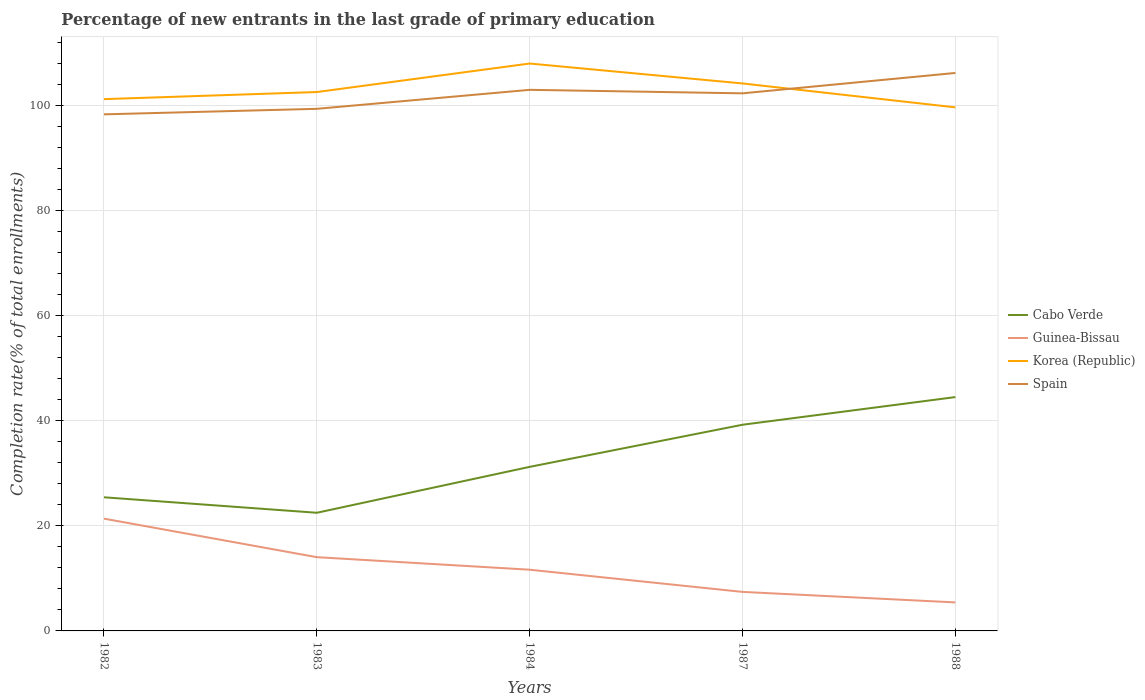How many different coloured lines are there?
Your answer should be compact. 4. Does the line corresponding to Cabo Verde intersect with the line corresponding to Korea (Republic)?
Keep it short and to the point. No. Is the number of lines equal to the number of legend labels?
Your answer should be very brief. Yes. Across all years, what is the maximum percentage of new entrants in Spain?
Offer a terse response. 98.31. What is the total percentage of new entrants in Cabo Verde in the graph?
Your answer should be very brief. -13.28. What is the difference between the highest and the second highest percentage of new entrants in Spain?
Provide a succinct answer. 7.88. What is the difference between the highest and the lowest percentage of new entrants in Korea (Republic)?
Your answer should be compact. 2. Is the percentage of new entrants in Cabo Verde strictly greater than the percentage of new entrants in Spain over the years?
Your answer should be compact. Yes. How many years are there in the graph?
Your response must be concise. 5. Where does the legend appear in the graph?
Make the answer very short. Center right. How many legend labels are there?
Keep it short and to the point. 4. What is the title of the graph?
Provide a short and direct response. Percentage of new entrants in the last grade of primary education. What is the label or title of the Y-axis?
Your answer should be compact. Completion rate(% of total enrollments). What is the Completion rate(% of total enrollments) in Cabo Verde in 1982?
Your answer should be compact. 25.43. What is the Completion rate(% of total enrollments) in Guinea-Bissau in 1982?
Offer a very short reply. 21.37. What is the Completion rate(% of total enrollments) of Korea (Republic) in 1982?
Your answer should be compact. 101.2. What is the Completion rate(% of total enrollments) in Spain in 1982?
Offer a very short reply. 98.31. What is the Completion rate(% of total enrollments) of Cabo Verde in 1983?
Make the answer very short. 22.48. What is the Completion rate(% of total enrollments) of Guinea-Bissau in 1983?
Ensure brevity in your answer.  14.03. What is the Completion rate(% of total enrollments) of Korea (Republic) in 1983?
Offer a terse response. 102.55. What is the Completion rate(% of total enrollments) in Spain in 1983?
Keep it short and to the point. 99.36. What is the Completion rate(% of total enrollments) of Cabo Verde in 1984?
Give a very brief answer. 31.22. What is the Completion rate(% of total enrollments) in Guinea-Bissau in 1984?
Keep it short and to the point. 11.65. What is the Completion rate(% of total enrollments) of Korea (Republic) in 1984?
Keep it short and to the point. 107.98. What is the Completion rate(% of total enrollments) in Spain in 1984?
Offer a terse response. 102.97. What is the Completion rate(% of total enrollments) in Cabo Verde in 1987?
Your response must be concise. 39.24. What is the Completion rate(% of total enrollments) of Guinea-Bissau in 1987?
Keep it short and to the point. 7.43. What is the Completion rate(% of total enrollments) in Korea (Republic) in 1987?
Ensure brevity in your answer.  104.18. What is the Completion rate(% of total enrollments) of Spain in 1987?
Offer a very short reply. 102.31. What is the Completion rate(% of total enrollments) in Cabo Verde in 1988?
Offer a terse response. 44.5. What is the Completion rate(% of total enrollments) in Guinea-Bissau in 1988?
Ensure brevity in your answer.  5.42. What is the Completion rate(% of total enrollments) of Korea (Republic) in 1988?
Offer a very short reply. 99.63. What is the Completion rate(% of total enrollments) in Spain in 1988?
Provide a short and direct response. 106.18. Across all years, what is the maximum Completion rate(% of total enrollments) in Cabo Verde?
Offer a very short reply. 44.5. Across all years, what is the maximum Completion rate(% of total enrollments) of Guinea-Bissau?
Offer a very short reply. 21.37. Across all years, what is the maximum Completion rate(% of total enrollments) in Korea (Republic)?
Your response must be concise. 107.98. Across all years, what is the maximum Completion rate(% of total enrollments) in Spain?
Give a very brief answer. 106.18. Across all years, what is the minimum Completion rate(% of total enrollments) in Cabo Verde?
Offer a terse response. 22.48. Across all years, what is the minimum Completion rate(% of total enrollments) in Guinea-Bissau?
Keep it short and to the point. 5.42. Across all years, what is the minimum Completion rate(% of total enrollments) in Korea (Republic)?
Offer a very short reply. 99.63. Across all years, what is the minimum Completion rate(% of total enrollments) in Spain?
Ensure brevity in your answer.  98.31. What is the total Completion rate(% of total enrollments) of Cabo Verde in the graph?
Your answer should be very brief. 162.87. What is the total Completion rate(% of total enrollments) in Guinea-Bissau in the graph?
Keep it short and to the point. 59.9. What is the total Completion rate(% of total enrollments) in Korea (Republic) in the graph?
Offer a very short reply. 515.55. What is the total Completion rate(% of total enrollments) in Spain in the graph?
Your answer should be very brief. 509.12. What is the difference between the Completion rate(% of total enrollments) in Cabo Verde in 1982 and that in 1983?
Your response must be concise. 2.95. What is the difference between the Completion rate(% of total enrollments) of Guinea-Bissau in 1982 and that in 1983?
Make the answer very short. 7.33. What is the difference between the Completion rate(% of total enrollments) of Korea (Republic) in 1982 and that in 1983?
Your answer should be very brief. -1.35. What is the difference between the Completion rate(% of total enrollments) of Spain in 1982 and that in 1983?
Your answer should be compact. -1.05. What is the difference between the Completion rate(% of total enrollments) of Cabo Verde in 1982 and that in 1984?
Offer a terse response. -5.79. What is the difference between the Completion rate(% of total enrollments) of Guinea-Bissau in 1982 and that in 1984?
Offer a very short reply. 9.72. What is the difference between the Completion rate(% of total enrollments) in Korea (Republic) in 1982 and that in 1984?
Give a very brief answer. -6.78. What is the difference between the Completion rate(% of total enrollments) of Spain in 1982 and that in 1984?
Give a very brief answer. -4.66. What is the difference between the Completion rate(% of total enrollments) in Cabo Verde in 1982 and that in 1987?
Make the answer very short. -13.81. What is the difference between the Completion rate(% of total enrollments) in Guinea-Bissau in 1982 and that in 1987?
Give a very brief answer. 13.94. What is the difference between the Completion rate(% of total enrollments) in Korea (Republic) in 1982 and that in 1987?
Provide a succinct answer. -2.98. What is the difference between the Completion rate(% of total enrollments) of Spain in 1982 and that in 1987?
Your response must be concise. -4. What is the difference between the Completion rate(% of total enrollments) of Cabo Verde in 1982 and that in 1988?
Give a very brief answer. -19.07. What is the difference between the Completion rate(% of total enrollments) in Guinea-Bissau in 1982 and that in 1988?
Provide a succinct answer. 15.94. What is the difference between the Completion rate(% of total enrollments) of Korea (Republic) in 1982 and that in 1988?
Ensure brevity in your answer.  1.57. What is the difference between the Completion rate(% of total enrollments) of Spain in 1982 and that in 1988?
Offer a very short reply. -7.88. What is the difference between the Completion rate(% of total enrollments) of Cabo Verde in 1983 and that in 1984?
Make the answer very short. -8.74. What is the difference between the Completion rate(% of total enrollments) in Guinea-Bissau in 1983 and that in 1984?
Provide a short and direct response. 2.39. What is the difference between the Completion rate(% of total enrollments) in Korea (Republic) in 1983 and that in 1984?
Your answer should be very brief. -5.43. What is the difference between the Completion rate(% of total enrollments) in Spain in 1983 and that in 1984?
Offer a very short reply. -3.61. What is the difference between the Completion rate(% of total enrollments) in Cabo Verde in 1983 and that in 1987?
Offer a terse response. -16.75. What is the difference between the Completion rate(% of total enrollments) of Guinea-Bissau in 1983 and that in 1987?
Your answer should be compact. 6.61. What is the difference between the Completion rate(% of total enrollments) in Korea (Republic) in 1983 and that in 1987?
Your answer should be compact. -1.63. What is the difference between the Completion rate(% of total enrollments) in Spain in 1983 and that in 1987?
Provide a short and direct response. -2.95. What is the difference between the Completion rate(% of total enrollments) in Cabo Verde in 1983 and that in 1988?
Provide a short and direct response. -22.01. What is the difference between the Completion rate(% of total enrollments) of Guinea-Bissau in 1983 and that in 1988?
Provide a succinct answer. 8.61. What is the difference between the Completion rate(% of total enrollments) in Korea (Republic) in 1983 and that in 1988?
Offer a very short reply. 2.92. What is the difference between the Completion rate(% of total enrollments) in Spain in 1983 and that in 1988?
Your response must be concise. -6.83. What is the difference between the Completion rate(% of total enrollments) in Cabo Verde in 1984 and that in 1987?
Your answer should be compact. -8.01. What is the difference between the Completion rate(% of total enrollments) in Guinea-Bissau in 1984 and that in 1987?
Give a very brief answer. 4.22. What is the difference between the Completion rate(% of total enrollments) in Korea (Republic) in 1984 and that in 1987?
Offer a terse response. 3.79. What is the difference between the Completion rate(% of total enrollments) of Spain in 1984 and that in 1987?
Offer a very short reply. 0.66. What is the difference between the Completion rate(% of total enrollments) of Cabo Verde in 1984 and that in 1988?
Offer a terse response. -13.28. What is the difference between the Completion rate(% of total enrollments) of Guinea-Bissau in 1984 and that in 1988?
Make the answer very short. 6.22. What is the difference between the Completion rate(% of total enrollments) of Korea (Republic) in 1984 and that in 1988?
Offer a terse response. 8.34. What is the difference between the Completion rate(% of total enrollments) of Spain in 1984 and that in 1988?
Your response must be concise. -3.21. What is the difference between the Completion rate(% of total enrollments) of Cabo Verde in 1987 and that in 1988?
Ensure brevity in your answer.  -5.26. What is the difference between the Completion rate(% of total enrollments) in Guinea-Bissau in 1987 and that in 1988?
Offer a very short reply. 2. What is the difference between the Completion rate(% of total enrollments) in Korea (Republic) in 1987 and that in 1988?
Make the answer very short. 4.55. What is the difference between the Completion rate(% of total enrollments) of Spain in 1987 and that in 1988?
Your answer should be compact. -3.88. What is the difference between the Completion rate(% of total enrollments) of Cabo Verde in 1982 and the Completion rate(% of total enrollments) of Guinea-Bissau in 1983?
Provide a succinct answer. 11.4. What is the difference between the Completion rate(% of total enrollments) of Cabo Verde in 1982 and the Completion rate(% of total enrollments) of Korea (Republic) in 1983?
Ensure brevity in your answer.  -77.12. What is the difference between the Completion rate(% of total enrollments) of Cabo Verde in 1982 and the Completion rate(% of total enrollments) of Spain in 1983?
Offer a very short reply. -73.93. What is the difference between the Completion rate(% of total enrollments) in Guinea-Bissau in 1982 and the Completion rate(% of total enrollments) in Korea (Republic) in 1983?
Keep it short and to the point. -81.18. What is the difference between the Completion rate(% of total enrollments) in Guinea-Bissau in 1982 and the Completion rate(% of total enrollments) in Spain in 1983?
Keep it short and to the point. -77.99. What is the difference between the Completion rate(% of total enrollments) of Korea (Republic) in 1982 and the Completion rate(% of total enrollments) of Spain in 1983?
Keep it short and to the point. 1.84. What is the difference between the Completion rate(% of total enrollments) in Cabo Verde in 1982 and the Completion rate(% of total enrollments) in Guinea-Bissau in 1984?
Provide a succinct answer. 13.78. What is the difference between the Completion rate(% of total enrollments) in Cabo Verde in 1982 and the Completion rate(% of total enrollments) in Korea (Republic) in 1984?
Ensure brevity in your answer.  -82.55. What is the difference between the Completion rate(% of total enrollments) of Cabo Verde in 1982 and the Completion rate(% of total enrollments) of Spain in 1984?
Offer a terse response. -77.54. What is the difference between the Completion rate(% of total enrollments) in Guinea-Bissau in 1982 and the Completion rate(% of total enrollments) in Korea (Republic) in 1984?
Your response must be concise. -86.61. What is the difference between the Completion rate(% of total enrollments) of Guinea-Bissau in 1982 and the Completion rate(% of total enrollments) of Spain in 1984?
Keep it short and to the point. -81.6. What is the difference between the Completion rate(% of total enrollments) in Korea (Republic) in 1982 and the Completion rate(% of total enrollments) in Spain in 1984?
Keep it short and to the point. -1.77. What is the difference between the Completion rate(% of total enrollments) of Cabo Verde in 1982 and the Completion rate(% of total enrollments) of Guinea-Bissau in 1987?
Your response must be concise. 18. What is the difference between the Completion rate(% of total enrollments) of Cabo Verde in 1982 and the Completion rate(% of total enrollments) of Korea (Republic) in 1987?
Your response must be concise. -78.75. What is the difference between the Completion rate(% of total enrollments) in Cabo Verde in 1982 and the Completion rate(% of total enrollments) in Spain in 1987?
Your answer should be very brief. -76.88. What is the difference between the Completion rate(% of total enrollments) in Guinea-Bissau in 1982 and the Completion rate(% of total enrollments) in Korea (Republic) in 1987?
Your answer should be compact. -82.82. What is the difference between the Completion rate(% of total enrollments) in Guinea-Bissau in 1982 and the Completion rate(% of total enrollments) in Spain in 1987?
Give a very brief answer. -80.94. What is the difference between the Completion rate(% of total enrollments) of Korea (Republic) in 1982 and the Completion rate(% of total enrollments) of Spain in 1987?
Provide a succinct answer. -1.11. What is the difference between the Completion rate(% of total enrollments) in Cabo Verde in 1982 and the Completion rate(% of total enrollments) in Guinea-Bissau in 1988?
Keep it short and to the point. 20.01. What is the difference between the Completion rate(% of total enrollments) in Cabo Verde in 1982 and the Completion rate(% of total enrollments) in Korea (Republic) in 1988?
Offer a terse response. -74.2. What is the difference between the Completion rate(% of total enrollments) in Cabo Verde in 1982 and the Completion rate(% of total enrollments) in Spain in 1988?
Your response must be concise. -80.75. What is the difference between the Completion rate(% of total enrollments) in Guinea-Bissau in 1982 and the Completion rate(% of total enrollments) in Korea (Republic) in 1988?
Your answer should be compact. -78.27. What is the difference between the Completion rate(% of total enrollments) of Guinea-Bissau in 1982 and the Completion rate(% of total enrollments) of Spain in 1988?
Provide a succinct answer. -84.82. What is the difference between the Completion rate(% of total enrollments) of Korea (Republic) in 1982 and the Completion rate(% of total enrollments) of Spain in 1988?
Provide a short and direct response. -4.98. What is the difference between the Completion rate(% of total enrollments) of Cabo Verde in 1983 and the Completion rate(% of total enrollments) of Guinea-Bissau in 1984?
Provide a succinct answer. 10.84. What is the difference between the Completion rate(% of total enrollments) of Cabo Verde in 1983 and the Completion rate(% of total enrollments) of Korea (Republic) in 1984?
Provide a succinct answer. -85.49. What is the difference between the Completion rate(% of total enrollments) of Cabo Verde in 1983 and the Completion rate(% of total enrollments) of Spain in 1984?
Provide a succinct answer. -80.49. What is the difference between the Completion rate(% of total enrollments) in Guinea-Bissau in 1983 and the Completion rate(% of total enrollments) in Korea (Republic) in 1984?
Offer a terse response. -93.94. What is the difference between the Completion rate(% of total enrollments) of Guinea-Bissau in 1983 and the Completion rate(% of total enrollments) of Spain in 1984?
Provide a short and direct response. -88.94. What is the difference between the Completion rate(% of total enrollments) in Korea (Republic) in 1983 and the Completion rate(% of total enrollments) in Spain in 1984?
Provide a succinct answer. -0.42. What is the difference between the Completion rate(% of total enrollments) of Cabo Verde in 1983 and the Completion rate(% of total enrollments) of Guinea-Bissau in 1987?
Provide a short and direct response. 15.06. What is the difference between the Completion rate(% of total enrollments) of Cabo Verde in 1983 and the Completion rate(% of total enrollments) of Korea (Republic) in 1987?
Provide a short and direct response. -81.7. What is the difference between the Completion rate(% of total enrollments) of Cabo Verde in 1983 and the Completion rate(% of total enrollments) of Spain in 1987?
Make the answer very short. -79.82. What is the difference between the Completion rate(% of total enrollments) of Guinea-Bissau in 1983 and the Completion rate(% of total enrollments) of Korea (Republic) in 1987?
Ensure brevity in your answer.  -90.15. What is the difference between the Completion rate(% of total enrollments) in Guinea-Bissau in 1983 and the Completion rate(% of total enrollments) in Spain in 1987?
Provide a short and direct response. -88.27. What is the difference between the Completion rate(% of total enrollments) of Korea (Republic) in 1983 and the Completion rate(% of total enrollments) of Spain in 1987?
Your answer should be very brief. 0.25. What is the difference between the Completion rate(% of total enrollments) of Cabo Verde in 1983 and the Completion rate(% of total enrollments) of Guinea-Bissau in 1988?
Provide a succinct answer. 17.06. What is the difference between the Completion rate(% of total enrollments) in Cabo Verde in 1983 and the Completion rate(% of total enrollments) in Korea (Republic) in 1988?
Your answer should be very brief. -77.15. What is the difference between the Completion rate(% of total enrollments) of Cabo Verde in 1983 and the Completion rate(% of total enrollments) of Spain in 1988?
Offer a terse response. -83.7. What is the difference between the Completion rate(% of total enrollments) in Guinea-Bissau in 1983 and the Completion rate(% of total enrollments) in Korea (Republic) in 1988?
Keep it short and to the point. -85.6. What is the difference between the Completion rate(% of total enrollments) in Guinea-Bissau in 1983 and the Completion rate(% of total enrollments) in Spain in 1988?
Give a very brief answer. -92.15. What is the difference between the Completion rate(% of total enrollments) in Korea (Republic) in 1983 and the Completion rate(% of total enrollments) in Spain in 1988?
Offer a very short reply. -3.63. What is the difference between the Completion rate(% of total enrollments) of Cabo Verde in 1984 and the Completion rate(% of total enrollments) of Guinea-Bissau in 1987?
Your answer should be compact. 23.8. What is the difference between the Completion rate(% of total enrollments) of Cabo Verde in 1984 and the Completion rate(% of total enrollments) of Korea (Republic) in 1987?
Make the answer very short. -72.96. What is the difference between the Completion rate(% of total enrollments) in Cabo Verde in 1984 and the Completion rate(% of total enrollments) in Spain in 1987?
Your response must be concise. -71.08. What is the difference between the Completion rate(% of total enrollments) in Guinea-Bissau in 1984 and the Completion rate(% of total enrollments) in Korea (Republic) in 1987?
Provide a short and direct response. -92.54. What is the difference between the Completion rate(% of total enrollments) in Guinea-Bissau in 1984 and the Completion rate(% of total enrollments) in Spain in 1987?
Offer a very short reply. -90.66. What is the difference between the Completion rate(% of total enrollments) in Korea (Republic) in 1984 and the Completion rate(% of total enrollments) in Spain in 1987?
Your answer should be compact. 5.67. What is the difference between the Completion rate(% of total enrollments) in Cabo Verde in 1984 and the Completion rate(% of total enrollments) in Guinea-Bissau in 1988?
Your response must be concise. 25.8. What is the difference between the Completion rate(% of total enrollments) of Cabo Verde in 1984 and the Completion rate(% of total enrollments) of Korea (Republic) in 1988?
Ensure brevity in your answer.  -68.41. What is the difference between the Completion rate(% of total enrollments) of Cabo Verde in 1984 and the Completion rate(% of total enrollments) of Spain in 1988?
Provide a succinct answer. -74.96. What is the difference between the Completion rate(% of total enrollments) in Guinea-Bissau in 1984 and the Completion rate(% of total enrollments) in Korea (Republic) in 1988?
Make the answer very short. -87.98. What is the difference between the Completion rate(% of total enrollments) in Guinea-Bissau in 1984 and the Completion rate(% of total enrollments) in Spain in 1988?
Offer a terse response. -94.53. What is the difference between the Completion rate(% of total enrollments) in Korea (Republic) in 1984 and the Completion rate(% of total enrollments) in Spain in 1988?
Offer a very short reply. 1.8. What is the difference between the Completion rate(% of total enrollments) in Cabo Verde in 1987 and the Completion rate(% of total enrollments) in Guinea-Bissau in 1988?
Your answer should be very brief. 33.81. What is the difference between the Completion rate(% of total enrollments) in Cabo Verde in 1987 and the Completion rate(% of total enrollments) in Korea (Republic) in 1988?
Your response must be concise. -60.4. What is the difference between the Completion rate(% of total enrollments) of Cabo Verde in 1987 and the Completion rate(% of total enrollments) of Spain in 1988?
Your answer should be compact. -66.95. What is the difference between the Completion rate(% of total enrollments) in Guinea-Bissau in 1987 and the Completion rate(% of total enrollments) in Korea (Republic) in 1988?
Provide a succinct answer. -92.21. What is the difference between the Completion rate(% of total enrollments) in Guinea-Bissau in 1987 and the Completion rate(% of total enrollments) in Spain in 1988?
Your response must be concise. -98.76. What is the difference between the Completion rate(% of total enrollments) of Korea (Republic) in 1987 and the Completion rate(% of total enrollments) of Spain in 1988?
Your answer should be very brief. -2. What is the average Completion rate(% of total enrollments) in Cabo Verde per year?
Your answer should be compact. 32.57. What is the average Completion rate(% of total enrollments) of Guinea-Bissau per year?
Keep it short and to the point. 11.98. What is the average Completion rate(% of total enrollments) in Korea (Republic) per year?
Provide a succinct answer. 103.11. What is the average Completion rate(% of total enrollments) of Spain per year?
Offer a very short reply. 101.82. In the year 1982, what is the difference between the Completion rate(% of total enrollments) in Cabo Verde and Completion rate(% of total enrollments) in Guinea-Bissau?
Offer a very short reply. 4.06. In the year 1982, what is the difference between the Completion rate(% of total enrollments) of Cabo Verde and Completion rate(% of total enrollments) of Korea (Republic)?
Ensure brevity in your answer.  -75.77. In the year 1982, what is the difference between the Completion rate(% of total enrollments) in Cabo Verde and Completion rate(% of total enrollments) in Spain?
Ensure brevity in your answer.  -72.88. In the year 1982, what is the difference between the Completion rate(% of total enrollments) of Guinea-Bissau and Completion rate(% of total enrollments) of Korea (Republic)?
Offer a terse response. -79.83. In the year 1982, what is the difference between the Completion rate(% of total enrollments) of Guinea-Bissau and Completion rate(% of total enrollments) of Spain?
Offer a terse response. -76.94. In the year 1982, what is the difference between the Completion rate(% of total enrollments) of Korea (Republic) and Completion rate(% of total enrollments) of Spain?
Make the answer very short. 2.89. In the year 1983, what is the difference between the Completion rate(% of total enrollments) of Cabo Verde and Completion rate(% of total enrollments) of Guinea-Bissau?
Your response must be concise. 8.45. In the year 1983, what is the difference between the Completion rate(% of total enrollments) in Cabo Verde and Completion rate(% of total enrollments) in Korea (Republic)?
Provide a short and direct response. -80.07. In the year 1983, what is the difference between the Completion rate(% of total enrollments) of Cabo Verde and Completion rate(% of total enrollments) of Spain?
Make the answer very short. -76.87. In the year 1983, what is the difference between the Completion rate(% of total enrollments) in Guinea-Bissau and Completion rate(% of total enrollments) in Korea (Republic)?
Provide a succinct answer. -88.52. In the year 1983, what is the difference between the Completion rate(% of total enrollments) of Guinea-Bissau and Completion rate(% of total enrollments) of Spain?
Make the answer very short. -85.32. In the year 1983, what is the difference between the Completion rate(% of total enrollments) in Korea (Republic) and Completion rate(% of total enrollments) in Spain?
Provide a short and direct response. 3.19. In the year 1984, what is the difference between the Completion rate(% of total enrollments) of Cabo Verde and Completion rate(% of total enrollments) of Guinea-Bissau?
Provide a short and direct response. 19.57. In the year 1984, what is the difference between the Completion rate(% of total enrollments) in Cabo Verde and Completion rate(% of total enrollments) in Korea (Republic)?
Provide a short and direct response. -76.76. In the year 1984, what is the difference between the Completion rate(% of total enrollments) in Cabo Verde and Completion rate(% of total enrollments) in Spain?
Ensure brevity in your answer.  -71.75. In the year 1984, what is the difference between the Completion rate(% of total enrollments) in Guinea-Bissau and Completion rate(% of total enrollments) in Korea (Republic)?
Give a very brief answer. -96.33. In the year 1984, what is the difference between the Completion rate(% of total enrollments) of Guinea-Bissau and Completion rate(% of total enrollments) of Spain?
Provide a short and direct response. -91.32. In the year 1984, what is the difference between the Completion rate(% of total enrollments) of Korea (Republic) and Completion rate(% of total enrollments) of Spain?
Your answer should be compact. 5.01. In the year 1987, what is the difference between the Completion rate(% of total enrollments) in Cabo Verde and Completion rate(% of total enrollments) in Guinea-Bissau?
Provide a succinct answer. 31.81. In the year 1987, what is the difference between the Completion rate(% of total enrollments) of Cabo Verde and Completion rate(% of total enrollments) of Korea (Republic)?
Your answer should be compact. -64.95. In the year 1987, what is the difference between the Completion rate(% of total enrollments) in Cabo Verde and Completion rate(% of total enrollments) in Spain?
Your answer should be compact. -63.07. In the year 1987, what is the difference between the Completion rate(% of total enrollments) of Guinea-Bissau and Completion rate(% of total enrollments) of Korea (Republic)?
Make the answer very short. -96.76. In the year 1987, what is the difference between the Completion rate(% of total enrollments) in Guinea-Bissau and Completion rate(% of total enrollments) in Spain?
Provide a succinct answer. -94.88. In the year 1987, what is the difference between the Completion rate(% of total enrollments) of Korea (Republic) and Completion rate(% of total enrollments) of Spain?
Your answer should be very brief. 1.88. In the year 1988, what is the difference between the Completion rate(% of total enrollments) in Cabo Verde and Completion rate(% of total enrollments) in Guinea-Bissau?
Your answer should be very brief. 39.07. In the year 1988, what is the difference between the Completion rate(% of total enrollments) in Cabo Verde and Completion rate(% of total enrollments) in Korea (Republic)?
Ensure brevity in your answer.  -55.14. In the year 1988, what is the difference between the Completion rate(% of total enrollments) of Cabo Verde and Completion rate(% of total enrollments) of Spain?
Provide a succinct answer. -61.68. In the year 1988, what is the difference between the Completion rate(% of total enrollments) of Guinea-Bissau and Completion rate(% of total enrollments) of Korea (Republic)?
Your answer should be compact. -94.21. In the year 1988, what is the difference between the Completion rate(% of total enrollments) in Guinea-Bissau and Completion rate(% of total enrollments) in Spain?
Provide a short and direct response. -100.76. In the year 1988, what is the difference between the Completion rate(% of total enrollments) in Korea (Republic) and Completion rate(% of total enrollments) in Spain?
Ensure brevity in your answer.  -6.55. What is the ratio of the Completion rate(% of total enrollments) in Cabo Verde in 1982 to that in 1983?
Provide a short and direct response. 1.13. What is the ratio of the Completion rate(% of total enrollments) in Guinea-Bissau in 1982 to that in 1983?
Your response must be concise. 1.52. What is the ratio of the Completion rate(% of total enrollments) in Cabo Verde in 1982 to that in 1984?
Provide a short and direct response. 0.81. What is the ratio of the Completion rate(% of total enrollments) of Guinea-Bissau in 1982 to that in 1984?
Provide a succinct answer. 1.83. What is the ratio of the Completion rate(% of total enrollments) of Korea (Republic) in 1982 to that in 1984?
Your response must be concise. 0.94. What is the ratio of the Completion rate(% of total enrollments) in Spain in 1982 to that in 1984?
Your response must be concise. 0.95. What is the ratio of the Completion rate(% of total enrollments) of Cabo Verde in 1982 to that in 1987?
Your response must be concise. 0.65. What is the ratio of the Completion rate(% of total enrollments) in Guinea-Bissau in 1982 to that in 1987?
Your answer should be compact. 2.88. What is the ratio of the Completion rate(% of total enrollments) in Korea (Republic) in 1982 to that in 1987?
Make the answer very short. 0.97. What is the ratio of the Completion rate(% of total enrollments) in Spain in 1982 to that in 1987?
Offer a very short reply. 0.96. What is the ratio of the Completion rate(% of total enrollments) in Cabo Verde in 1982 to that in 1988?
Make the answer very short. 0.57. What is the ratio of the Completion rate(% of total enrollments) in Guinea-Bissau in 1982 to that in 1988?
Ensure brevity in your answer.  3.94. What is the ratio of the Completion rate(% of total enrollments) in Korea (Republic) in 1982 to that in 1988?
Ensure brevity in your answer.  1.02. What is the ratio of the Completion rate(% of total enrollments) of Spain in 1982 to that in 1988?
Your answer should be very brief. 0.93. What is the ratio of the Completion rate(% of total enrollments) of Cabo Verde in 1983 to that in 1984?
Provide a short and direct response. 0.72. What is the ratio of the Completion rate(% of total enrollments) of Guinea-Bissau in 1983 to that in 1984?
Keep it short and to the point. 1.2. What is the ratio of the Completion rate(% of total enrollments) in Korea (Republic) in 1983 to that in 1984?
Offer a terse response. 0.95. What is the ratio of the Completion rate(% of total enrollments) in Spain in 1983 to that in 1984?
Your answer should be compact. 0.96. What is the ratio of the Completion rate(% of total enrollments) in Cabo Verde in 1983 to that in 1987?
Offer a very short reply. 0.57. What is the ratio of the Completion rate(% of total enrollments) in Guinea-Bissau in 1983 to that in 1987?
Your answer should be compact. 1.89. What is the ratio of the Completion rate(% of total enrollments) of Korea (Republic) in 1983 to that in 1987?
Your answer should be compact. 0.98. What is the ratio of the Completion rate(% of total enrollments) in Spain in 1983 to that in 1987?
Offer a terse response. 0.97. What is the ratio of the Completion rate(% of total enrollments) of Cabo Verde in 1983 to that in 1988?
Provide a succinct answer. 0.51. What is the ratio of the Completion rate(% of total enrollments) in Guinea-Bissau in 1983 to that in 1988?
Offer a very short reply. 2.59. What is the ratio of the Completion rate(% of total enrollments) of Korea (Republic) in 1983 to that in 1988?
Provide a succinct answer. 1.03. What is the ratio of the Completion rate(% of total enrollments) of Spain in 1983 to that in 1988?
Ensure brevity in your answer.  0.94. What is the ratio of the Completion rate(% of total enrollments) of Cabo Verde in 1984 to that in 1987?
Your answer should be very brief. 0.8. What is the ratio of the Completion rate(% of total enrollments) of Guinea-Bissau in 1984 to that in 1987?
Offer a terse response. 1.57. What is the ratio of the Completion rate(% of total enrollments) in Korea (Republic) in 1984 to that in 1987?
Your response must be concise. 1.04. What is the ratio of the Completion rate(% of total enrollments) of Spain in 1984 to that in 1987?
Give a very brief answer. 1.01. What is the ratio of the Completion rate(% of total enrollments) in Cabo Verde in 1984 to that in 1988?
Your answer should be compact. 0.7. What is the ratio of the Completion rate(% of total enrollments) in Guinea-Bissau in 1984 to that in 1988?
Offer a very short reply. 2.15. What is the ratio of the Completion rate(% of total enrollments) of Korea (Republic) in 1984 to that in 1988?
Ensure brevity in your answer.  1.08. What is the ratio of the Completion rate(% of total enrollments) of Spain in 1984 to that in 1988?
Offer a very short reply. 0.97. What is the ratio of the Completion rate(% of total enrollments) in Cabo Verde in 1987 to that in 1988?
Ensure brevity in your answer.  0.88. What is the ratio of the Completion rate(% of total enrollments) in Guinea-Bissau in 1987 to that in 1988?
Provide a short and direct response. 1.37. What is the ratio of the Completion rate(% of total enrollments) of Korea (Republic) in 1987 to that in 1988?
Keep it short and to the point. 1.05. What is the ratio of the Completion rate(% of total enrollments) of Spain in 1987 to that in 1988?
Make the answer very short. 0.96. What is the difference between the highest and the second highest Completion rate(% of total enrollments) of Cabo Verde?
Offer a terse response. 5.26. What is the difference between the highest and the second highest Completion rate(% of total enrollments) of Guinea-Bissau?
Make the answer very short. 7.33. What is the difference between the highest and the second highest Completion rate(% of total enrollments) in Korea (Republic)?
Ensure brevity in your answer.  3.79. What is the difference between the highest and the second highest Completion rate(% of total enrollments) in Spain?
Provide a succinct answer. 3.21. What is the difference between the highest and the lowest Completion rate(% of total enrollments) of Cabo Verde?
Provide a succinct answer. 22.01. What is the difference between the highest and the lowest Completion rate(% of total enrollments) of Guinea-Bissau?
Your answer should be compact. 15.94. What is the difference between the highest and the lowest Completion rate(% of total enrollments) in Korea (Republic)?
Provide a succinct answer. 8.34. What is the difference between the highest and the lowest Completion rate(% of total enrollments) in Spain?
Provide a succinct answer. 7.88. 